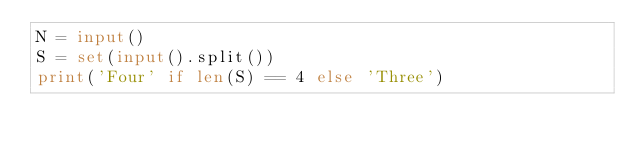<code> <loc_0><loc_0><loc_500><loc_500><_Python_>N = input()
S = set(input().split())
print('Four' if len(S) == 4 else 'Three')</code> 